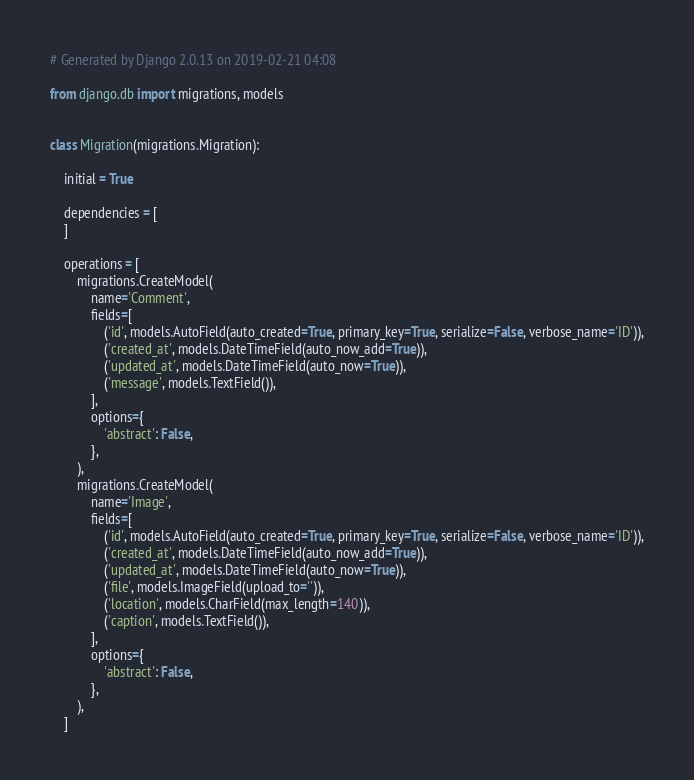Convert code to text. <code><loc_0><loc_0><loc_500><loc_500><_Python_># Generated by Django 2.0.13 on 2019-02-21 04:08

from django.db import migrations, models


class Migration(migrations.Migration):

    initial = True

    dependencies = [
    ]

    operations = [
        migrations.CreateModel(
            name='Comment',
            fields=[
                ('id', models.AutoField(auto_created=True, primary_key=True, serialize=False, verbose_name='ID')),
                ('created_at', models.DateTimeField(auto_now_add=True)),
                ('updated_at', models.DateTimeField(auto_now=True)),
                ('message', models.TextField()),
            ],
            options={
                'abstract': False,
            },
        ),
        migrations.CreateModel(
            name='Image',
            fields=[
                ('id', models.AutoField(auto_created=True, primary_key=True, serialize=False, verbose_name='ID')),
                ('created_at', models.DateTimeField(auto_now_add=True)),
                ('updated_at', models.DateTimeField(auto_now=True)),
                ('file', models.ImageField(upload_to='')),
                ('location', models.CharField(max_length=140)),
                ('caption', models.TextField()),
            ],
            options={
                'abstract': False,
            },
        ),
    ]
</code> 